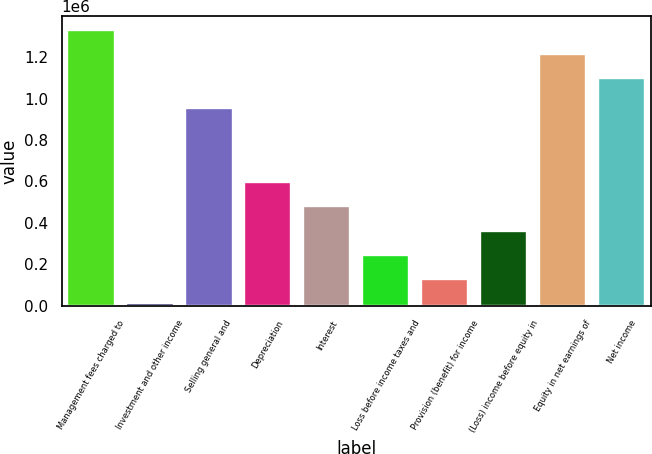<chart> <loc_0><loc_0><loc_500><loc_500><bar_chart><fcel>Management fees charged to<fcel>Investment and other income<fcel>Selling general and<fcel>Depreciation<fcel>Interest<fcel>Loss before income taxes and<fcel>Provision (benefit) for income<fcel>(Loss) income before equity in<fcel>Equity in net earnings of<fcel>Net income<nl><fcel>1.3316e+06<fcel>14210<fcel>955494<fcel>594728<fcel>478625<fcel>246417<fcel>130314<fcel>362521<fcel>1.21549e+06<fcel>1.09939e+06<nl></chart> 